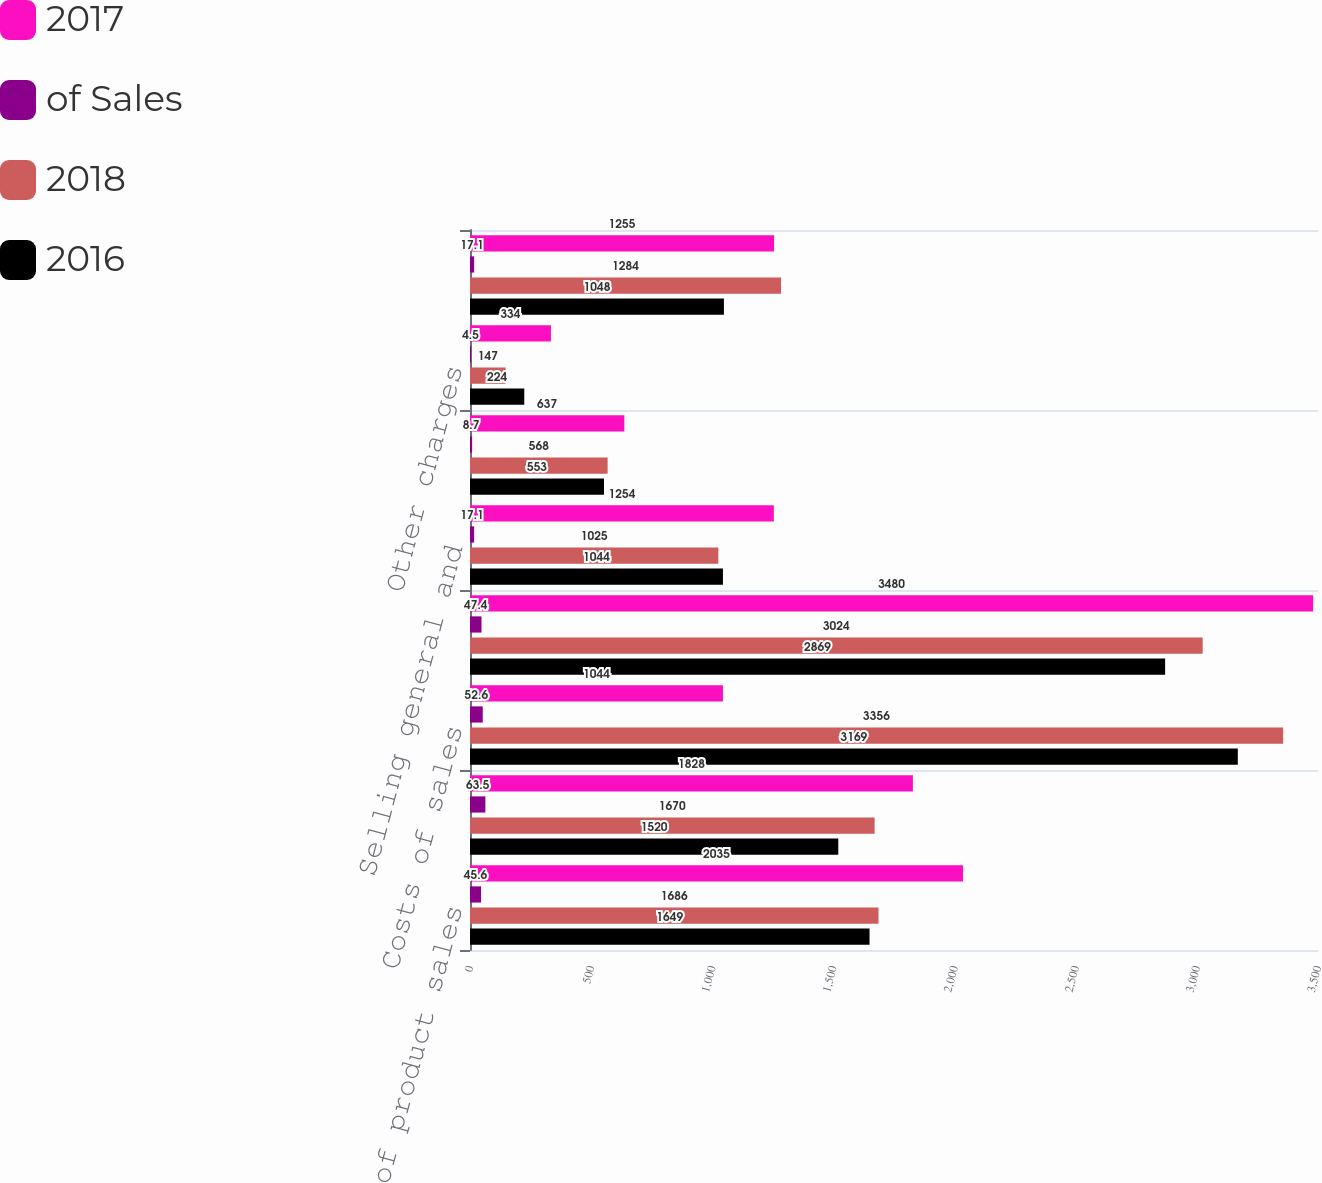Convert chart to OTSL. <chart><loc_0><loc_0><loc_500><loc_500><stacked_bar_chart><ecel><fcel>Costs of product sales<fcel>Costs of services sales<fcel>Costs of sales<fcel>Gross margin<fcel>Selling general and<fcel>Research and development<fcel>Other charges<fcel>Operating earnings<nl><fcel>2017<fcel>2035<fcel>1828<fcel>1044<fcel>3480<fcel>1254<fcel>637<fcel>334<fcel>1255<nl><fcel>of Sales<fcel>45.6<fcel>63.5<fcel>52.6<fcel>47.4<fcel>17.1<fcel>8.7<fcel>4.5<fcel>17.1<nl><fcel>2018<fcel>1686<fcel>1670<fcel>3356<fcel>3024<fcel>1025<fcel>568<fcel>147<fcel>1284<nl><fcel>2016<fcel>1649<fcel>1520<fcel>3169<fcel>2869<fcel>1044<fcel>553<fcel>224<fcel>1048<nl></chart> 